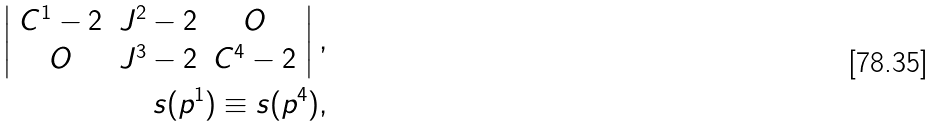<formula> <loc_0><loc_0><loc_500><loc_500>\left | \begin{array} { c c c } C ^ { 1 } - 2 & J ^ { 2 } - 2 & O \\ O & J ^ { 3 } - 2 & C ^ { 4 } - 2 \\ \end{array} \right | , \\ s ( p ^ { 1 } ) \equiv s ( p ^ { 4 } ) ,</formula> 